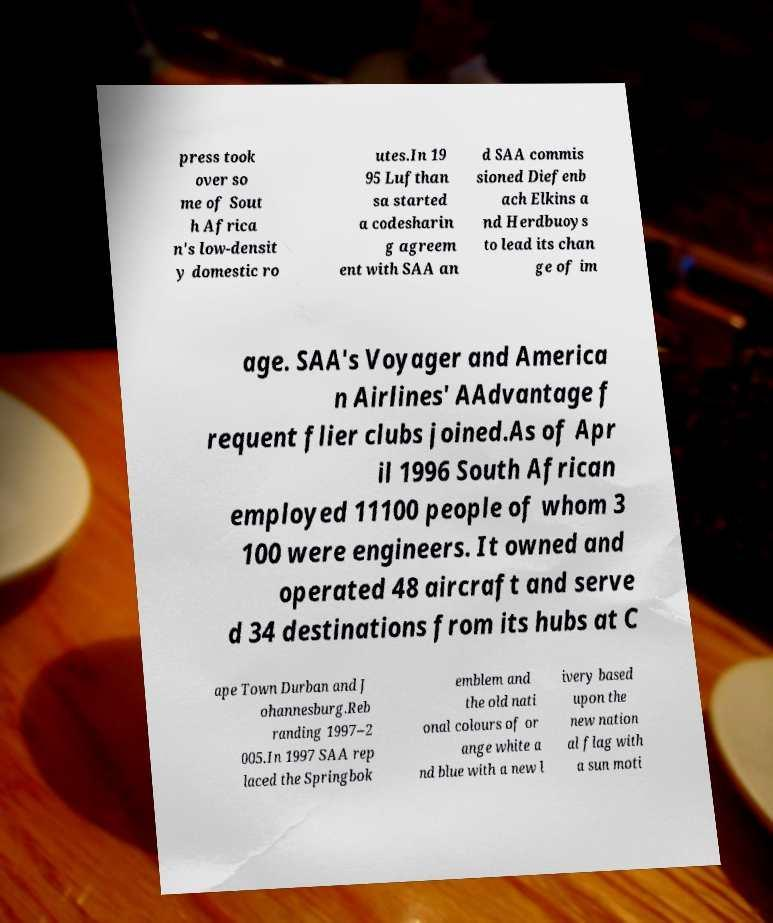What messages or text are displayed in this image? I need them in a readable, typed format. press took over so me of Sout h Africa n's low-densit y domestic ro utes.In 19 95 Lufthan sa started a codesharin g agreem ent with SAA an d SAA commis sioned Diefenb ach Elkins a nd Herdbuoys to lead its chan ge of im age. SAA's Voyager and America n Airlines' AAdvantage f requent flier clubs joined.As of Apr il 1996 South African employed 11100 people of whom 3 100 were engineers. It owned and operated 48 aircraft and serve d 34 destinations from its hubs at C ape Town Durban and J ohannesburg.Reb randing 1997–2 005.In 1997 SAA rep laced the Springbok emblem and the old nati onal colours of or ange white a nd blue with a new l ivery based upon the new nation al flag with a sun moti 